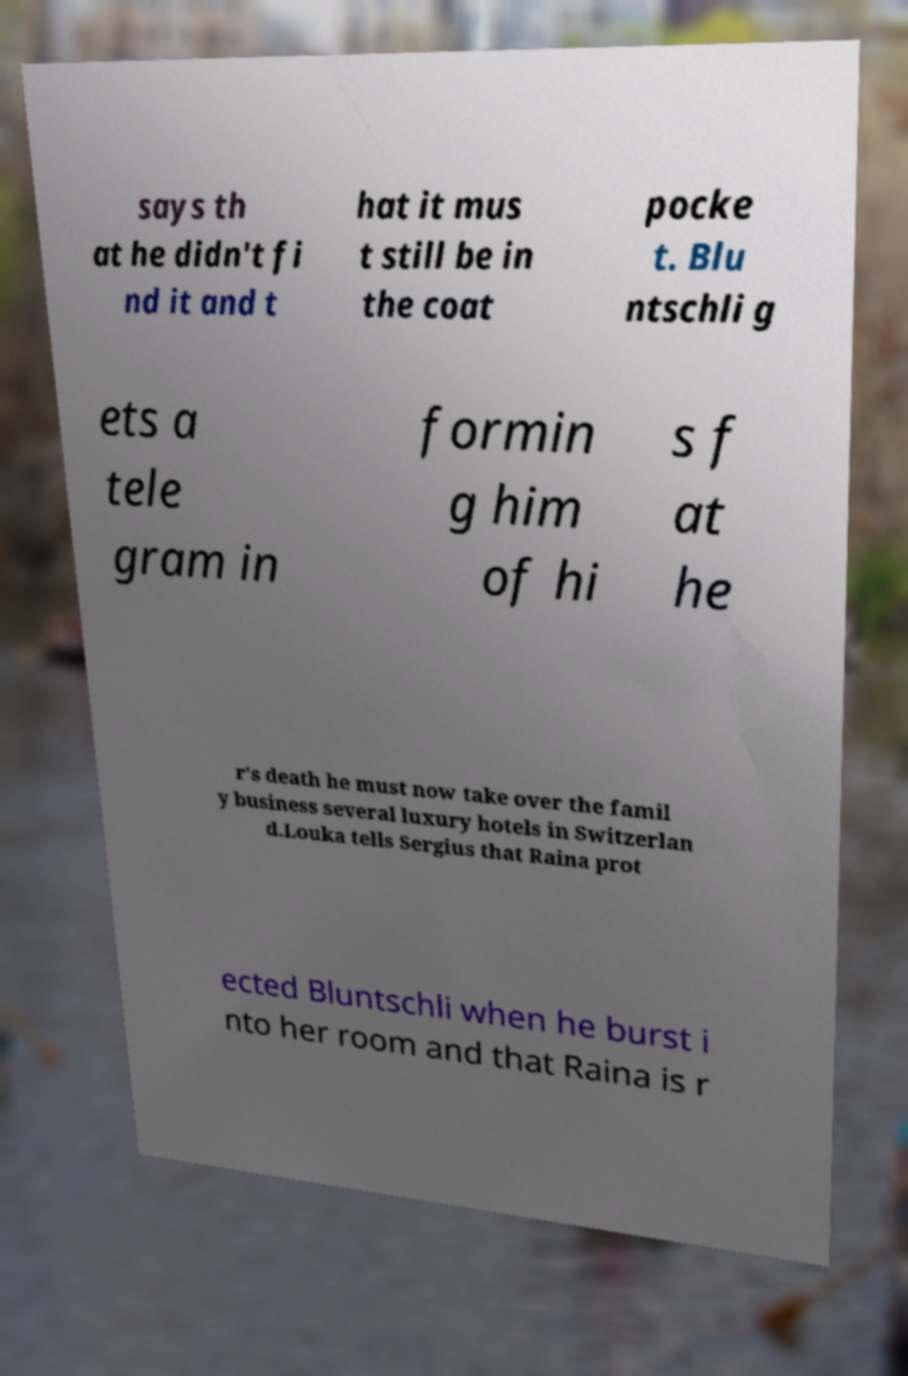Please identify and transcribe the text found in this image. says th at he didn't fi nd it and t hat it mus t still be in the coat pocke t. Blu ntschli g ets a tele gram in formin g him of hi s f at he r's death he must now take over the famil y business several luxury hotels in Switzerlan d.Louka tells Sergius that Raina prot ected Bluntschli when he burst i nto her room and that Raina is r 